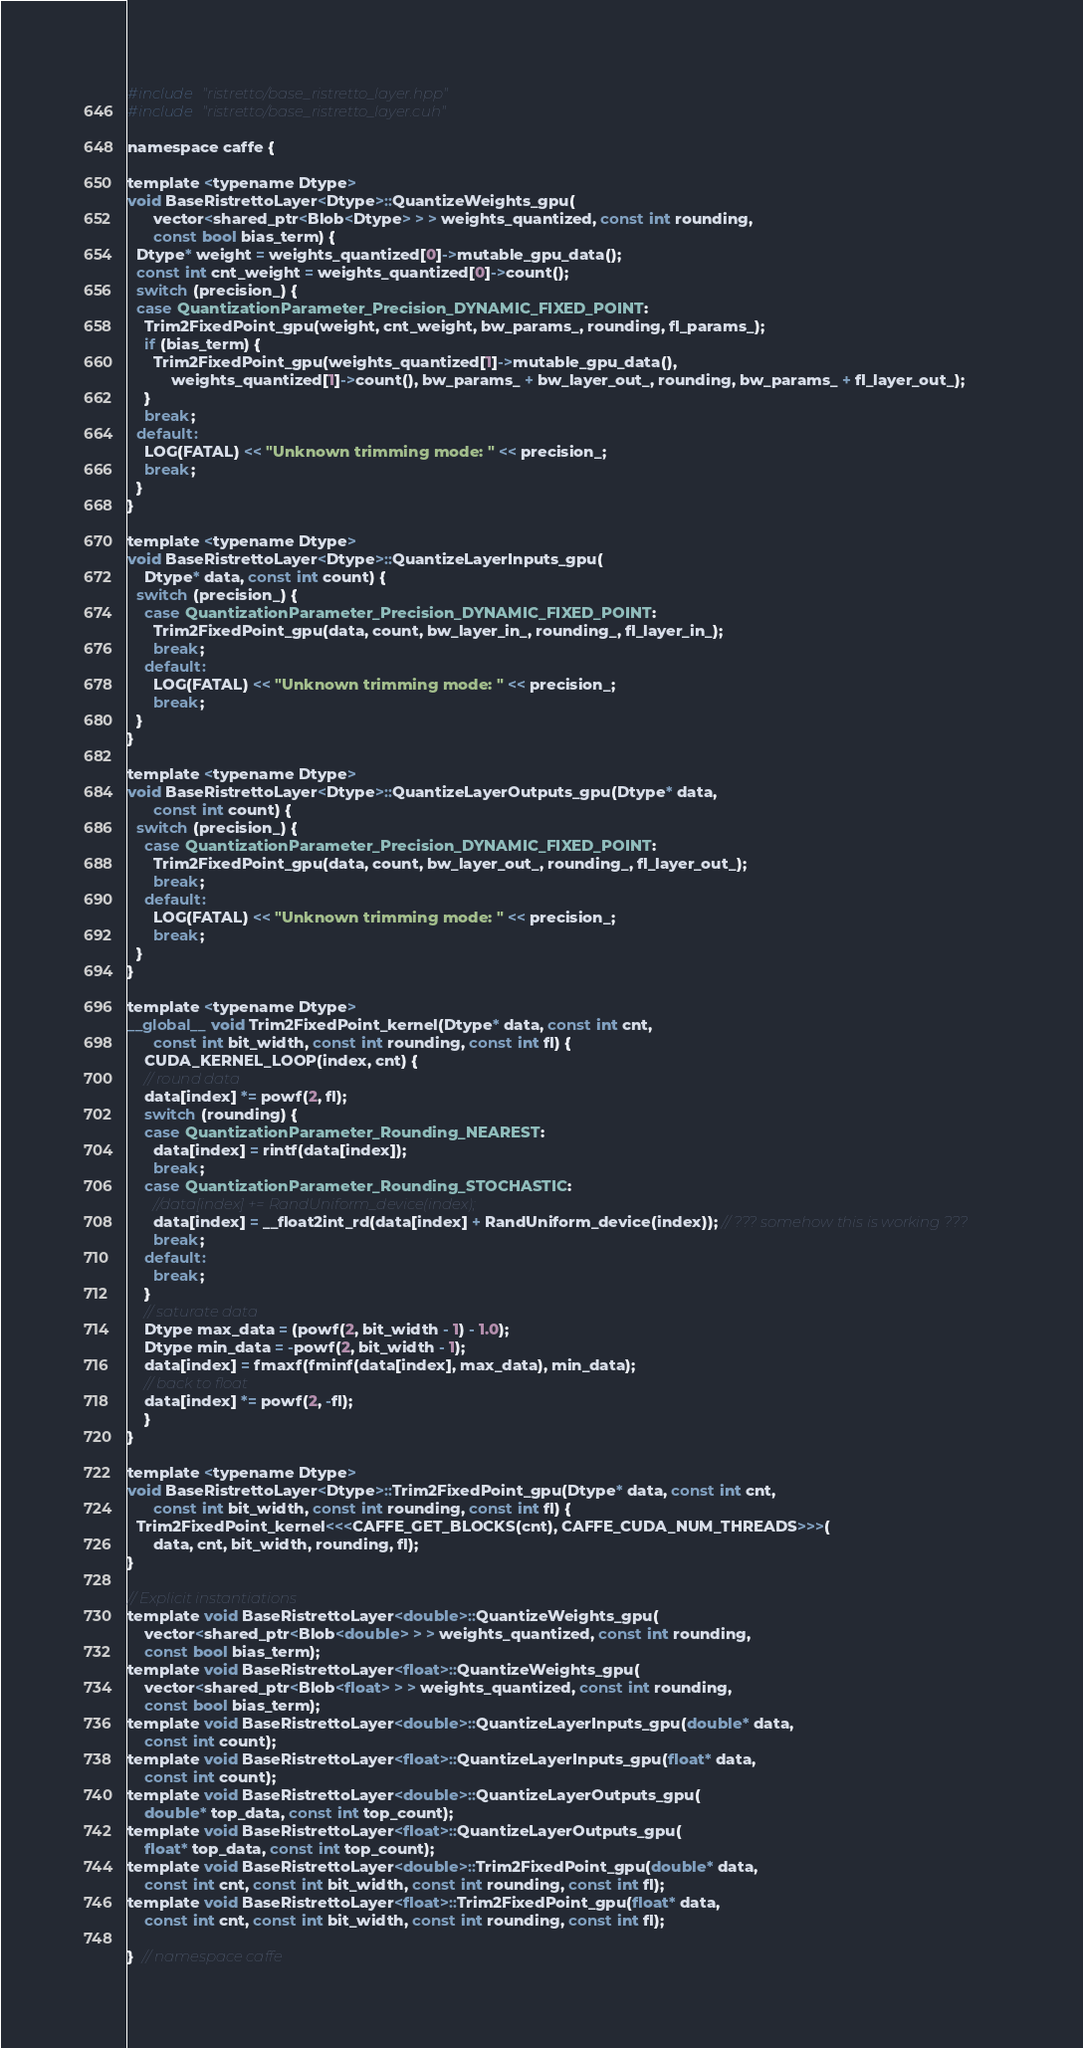<code> <loc_0><loc_0><loc_500><loc_500><_Cuda_>#include "ristretto/base_ristretto_layer.hpp"
#include "ristretto/base_ristretto_layer.cuh"

namespace caffe {

template <typename Dtype>
void BaseRistrettoLayer<Dtype>::QuantizeWeights_gpu(
      vector<shared_ptr<Blob<Dtype> > > weights_quantized, const int rounding,
      const bool bias_term) {
  Dtype* weight = weights_quantized[0]->mutable_gpu_data();
  const int cnt_weight = weights_quantized[0]->count();
  switch (precision_) {
  case QuantizationParameter_Precision_DYNAMIC_FIXED_POINT:
    Trim2FixedPoint_gpu(weight, cnt_weight, bw_params_, rounding, fl_params_);
    if (bias_term) {
      Trim2FixedPoint_gpu(weights_quantized[1]->mutable_gpu_data(),
          weights_quantized[1]->count(), bw_params_ + bw_layer_out_, rounding, bw_params_ + fl_layer_out_);
    }
    break;
  default:
    LOG(FATAL) << "Unknown trimming mode: " << precision_;
    break;
  }
}

template <typename Dtype>
void BaseRistrettoLayer<Dtype>::QuantizeLayerInputs_gpu(
    Dtype* data, const int count) {
  switch (precision_) {
    case QuantizationParameter_Precision_DYNAMIC_FIXED_POINT:
      Trim2FixedPoint_gpu(data, count, bw_layer_in_, rounding_, fl_layer_in_);
      break;
    default:
      LOG(FATAL) << "Unknown trimming mode: " << precision_;
      break;
  }
}

template <typename Dtype>
void BaseRistrettoLayer<Dtype>::QuantizeLayerOutputs_gpu(Dtype* data,
      const int count) {
  switch (precision_) {
    case QuantizationParameter_Precision_DYNAMIC_FIXED_POINT:
      Trim2FixedPoint_gpu(data, count, bw_layer_out_, rounding_, fl_layer_out_);
      break;
    default:
      LOG(FATAL) << "Unknown trimming mode: " << precision_;
      break;
  }
}

template <typename Dtype>
__global__ void Trim2FixedPoint_kernel(Dtype* data, const int cnt,
      const int bit_width, const int rounding, const int fl) {
	CUDA_KERNEL_LOOP(index, cnt) {
    // round data
    data[index] *= powf(2, fl);
    switch (rounding) {
    case QuantizationParameter_Rounding_NEAREST:
      data[index] = rintf(data[index]);
      break;
    case QuantizationParameter_Rounding_STOCHASTIC:
      //data[index] += RandUniform_device(index);
      data[index] = __float2int_rd(data[index] + RandUniform_device(index)); // ??? somehow this is working ???
      break;
    default:
      break;
    }
    // saturate data
    Dtype max_data = (powf(2, bit_width - 1) - 1.0);
    Dtype min_data = -powf(2, bit_width - 1);
    data[index] = fmaxf(fminf(data[index], max_data), min_data);
    // back to float
    data[index] *= powf(2, -fl);
	}
}

template <typename Dtype>
void BaseRistrettoLayer<Dtype>::Trim2FixedPoint_gpu(Dtype* data, const int cnt,
      const int bit_width, const int rounding, const int fl) {
  Trim2FixedPoint_kernel<<<CAFFE_GET_BLOCKS(cnt), CAFFE_CUDA_NUM_THREADS>>>(
      data, cnt, bit_width, rounding, fl);
}

// Explicit instantiations
template void BaseRistrettoLayer<double>::QuantizeWeights_gpu(
    vector<shared_ptr<Blob<double> > > weights_quantized, const int rounding,
    const bool bias_term);
template void BaseRistrettoLayer<float>::QuantizeWeights_gpu(
    vector<shared_ptr<Blob<float> > > weights_quantized, const int rounding,
    const bool bias_term);
template void BaseRistrettoLayer<double>::QuantizeLayerInputs_gpu(double* data,
    const int count);
template void BaseRistrettoLayer<float>::QuantizeLayerInputs_gpu(float* data,
    const int count);
template void BaseRistrettoLayer<double>::QuantizeLayerOutputs_gpu(
    double* top_data, const int top_count);
template void BaseRistrettoLayer<float>::QuantizeLayerOutputs_gpu(
    float* top_data, const int top_count);
template void BaseRistrettoLayer<double>::Trim2FixedPoint_gpu(double* data,
    const int cnt, const int bit_width, const int rounding, const int fl);
template void BaseRistrettoLayer<float>::Trim2FixedPoint_gpu(float* data,
    const int cnt, const int bit_width, const int rounding, const int fl);

}  // namespace caffe
</code> 